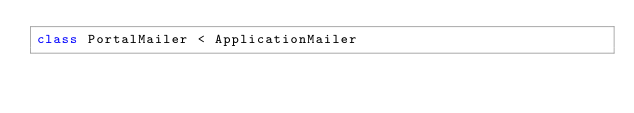<code> <loc_0><loc_0><loc_500><loc_500><_Ruby_>class PortalMailer < ApplicationMailer
  </code> 